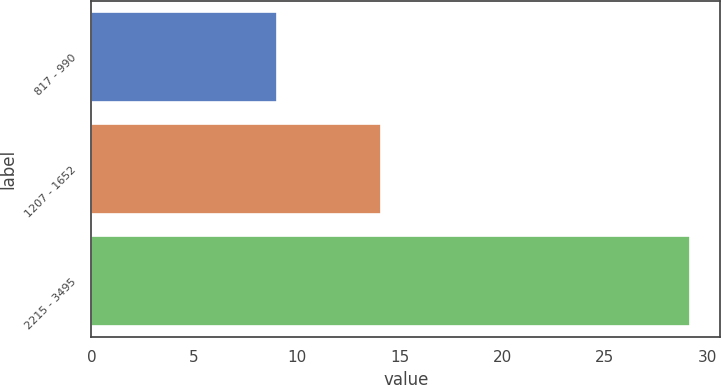Convert chart. <chart><loc_0><loc_0><loc_500><loc_500><bar_chart><fcel>817 - 990<fcel>1207 - 1652<fcel>2215 - 3495<nl><fcel>9.02<fcel>14.12<fcel>29.14<nl></chart> 